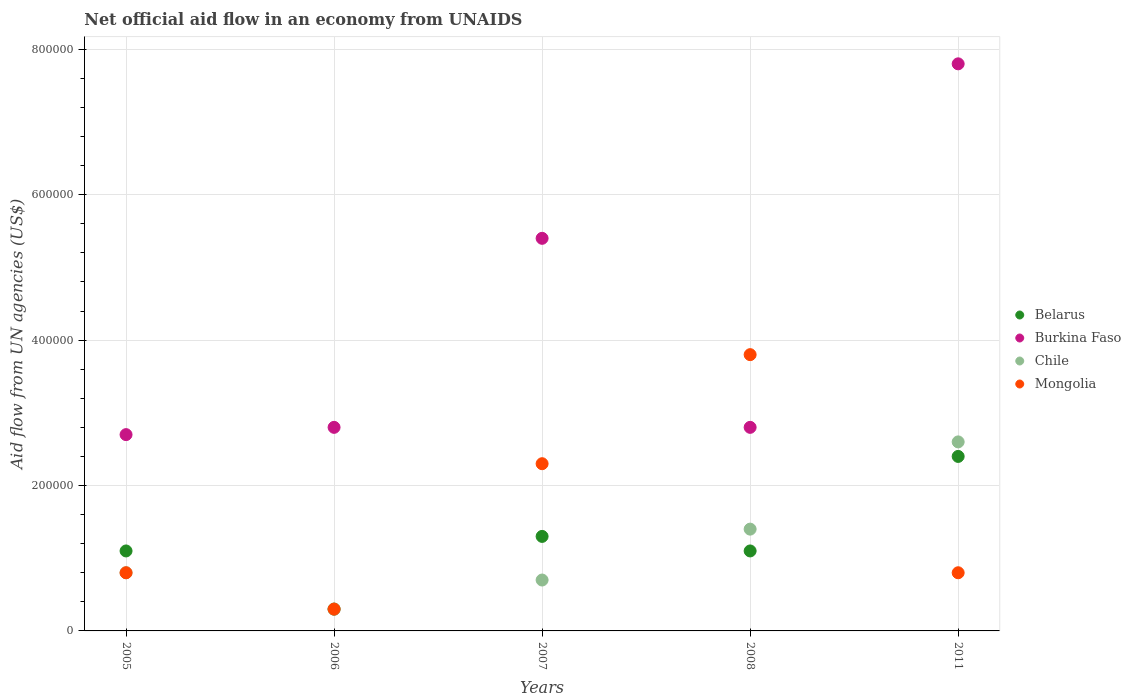Is the number of dotlines equal to the number of legend labels?
Offer a terse response. Yes. What is the net official aid flow in Burkina Faso in 2005?
Your answer should be very brief. 2.70e+05. Across all years, what is the minimum net official aid flow in Belarus?
Ensure brevity in your answer.  3.00e+04. In which year was the net official aid flow in Chile minimum?
Provide a succinct answer. 2006. What is the total net official aid flow in Belarus in the graph?
Keep it short and to the point. 6.20e+05. What is the difference between the net official aid flow in Mongolia in 2005 and the net official aid flow in Belarus in 2007?
Keep it short and to the point. -5.00e+04. What is the average net official aid flow in Belarus per year?
Provide a short and direct response. 1.24e+05. In the year 2008, what is the difference between the net official aid flow in Mongolia and net official aid flow in Chile?
Ensure brevity in your answer.  2.40e+05. What is the ratio of the net official aid flow in Belarus in 2006 to that in 2011?
Ensure brevity in your answer.  0.12. What is the difference between the highest and the second highest net official aid flow in Belarus?
Provide a succinct answer. 1.10e+05. Is it the case that in every year, the sum of the net official aid flow in Belarus and net official aid flow in Mongolia  is greater than the net official aid flow in Chile?
Your response must be concise. Yes. Is the net official aid flow in Mongolia strictly less than the net official aid flow in Chile over the years?
Give a very brief answer. No. How many dotlines are there?
Give a very brief answer. 4. How many years are there in the graph?
Give a very brief answer. 5. What is the difference between two consecutive major ticks on the Y-axis?
Provide a short and direct response. 2.00e+05. How are the legend labels stacked?
Offer a terse response. Vertical. What is the title of the graph?
Your answer should be compact. Net official aid flow in an economy from UNAIDS. What is the label or title of the Y-axis?
Make the answer very short. Aid flow from UN agencies (US$). What is the Aid flow from UN agencies (US$) of Belarus in 2005?
Offer a terse response. 1.10e+05. What is the Aid flow from UN agencies (US$) in Mongolia in 2005?
Offer a very short reply. 8.00e+04. What is the Aid flow from UN agencies (US$) of Chile in 2006?
Ensure brevity in your answer.  3.00e+04. What is the Aid flow from UN agencies (US$) in Belarus in 2007?
Make the answer very short. 1.30e+05. What is the Aid flow from UN agencies (US$) of Burkina Faso in 2007?
Offer a terse response. 5.40e+05. What is the Aid flow from UN agencies (US$) of Mongolia in 2007?
Give a very brief answer. 2.30e+05. What is the Aid flow from UN agencies (US$) in Mongolia in 2008?
Ensure brevity in your answer.  3.80e+05. What is the Aid flow from UN agencies (US$) of Belarus in 2011?
Offer a terse response. 2.40e+05. What is the Aid flow from UN agencies (US$) in Burkina Faso in 2011?
Make the answer very short. 7.80e+05. What is the Aid flow from UN agencies (US$) of Chile in 2011?
Provide a short and direct response. 2.60e+05. Across all years, what is the maximum Aid flow from UN agencies (US$) in Burkina Faso?
Your answer should be very brief. 7.80e+05. Across all years, what is the maximum Aid flow from UN agencies (US$) of Chile?
Ensure brevity in your answer.  2.60e+05. Across all years, what is the maximum Aid flow from UN agencies (US$) of Mongolia?
Your answer should be very brief. 3.80e+05. Across all years, what is the minimum Aid flow from UN agencies (US$) in Belarus?
Provide a succinct answer. 3.00e+04. What is the total Aid flow from UN agencies (US$) of Belarus in the graph?
Your response must be concise. 6.20e+05. What is the total Aid flow from UN agencies (US$) of Burkina Faso in the graph?
Provide a short and direct response. 2.15e+06. What is the total Aid flow from UN agencies (US$) in Chile in the graph?
Offer a very short reply. 5.80e+05. What is the difference between the Aid flow from UN agencies (US$) in Burkina Faso in 2005 and that in 2006?
Ensure brevity in your answer.  -10000. What is the difference between the Aid flow from UN agencies (US$) in Chile in 2005 and that in 2007?
Your answer should be compact. 10000. What is the difference between the Aid flow from UN agencies (US$) in Mongolia in 2005 and that in 2007?
Offer a terse response. -1.50e+05. What is the difference between the Aid flow from UN agencies (US$) in Chile in 2005 and that in 2008?
Your answer should be compact. -6.00e+04. What is the difference between the Aid flow from UN agencies (US$) of Burkina Faso in 2005 and that in 2011?
Keep it short and to the point. -5.10e+05. What is the difference between the Aid flow from UN agencies (US$) in Mongolia in 2005 and that in 2011?
Ensure brevity in your answer.  0. What is the difference between the Aid flow from UN agencies (US$) in Belarus in 2006 and that in 2007?
Offer a very short reply. -1.00e+05. What is the difference between the Aid flow from UN agencies (US$) of Chile in 2006 and that in 2007?
Provide a short and direct response. -4.00e+04. What is the difference between the Aid flow from UN agencies (US$) in Burkina Faso in 2006 and that in 2008?
Your response must be concise. 0. What is the difference between the Aid flow from UN agencies (US$) in Mongolia in 2006 and that in 2008?
Ensure brevity in your answer.  -3.50e+05. What is the difference between the Aid flow from UN agencies (US$) of Belarus in 2006 and that in 2011?
Offer a very short reply. -2.10e+05. What is the difference between the Aid flow from UN agencies (US$) of Burkina Faso in 2006 and that in 2011?
Provide a succinct answer. -5.00e+05. What is the difference between the Aid flow from UN agencies (US$) in Mongolia in 2007 and that in 2011?
Provide a succinct answer. 1.50e+05. What is the difference between the Aid flow from UN agencies (US$) of Burkina Faso in 2008 and that in 2011?
Make the answer very short. -5.00e+05. What is the difference between the Aid flow from UN agencies (US$) in Chile in 2008 and that in 2011?
Give a very brief answer. -1.20e+05. What is the difference between the Aid flow from UN agencies (US$) of Belarus in 2005 and the Aid flow from UN agencies (US$) of Burkina Faso in 2006?
Offer a terse response. -1.70e+05. What is the difference between the Aid flow from UN agencies (US$) of Belarus in 2005 and the Aid flow from UN agencies (US$) of Chile in 2006?
Make the answer very short. 8.00e+04. What is the difference between the Aid flow from UN agencies (US$) in Burkina Faso in 2005 and the Aid flow from UN agencies (US$) in Chile in 2006?
Your response must be concise. 2.40e+05. What is the difference between the Aid flow from UN agencies (US$) of Burkina Faso in 2005 and the Aid flow from UN agencies (US$) of Mongolia in 2006?
Make the answer very short. 2.40e+05. What is the difference between the Aid flow from UN agencies (US$) of Chile in 2005 and the Aid flow from UN agencies (US$) of Mongolia in 2006?
Give a very brief answer. 5.00e+04. What is the difference between the Aid flow from UN agencies (US$) of Belarus in 2005 and the Aid flow from UN agencies (US$) of Burkina Faso in 2007?
Give a very brief answer. -4.30e+05. What is the difference between the Aid flow from UN agencies (US$) of Belarus in 2005 and the Aid flow from UN agencies (US$) of Mongolia in 2007?
Provide a succinct answer. -1.20e+05. What is the difference between the Aid flow from UN agencies (US$) in Burkina Faso in 2005 and the Aid flow from UN agencies (US$) in Chile in 2007?
Keep it short and to the point. 2.00e+05. What is the difference between the Aid flow from UN agencies (US$) in Burkina Faso in 2005 and the Aid flow from UN agencies (US$) in Mongolia in 2007?
Ensure brevity in your answer.  4.00e+04. What is the difference between the Aid flow from UN agencies (US$) of Chile in 2005 and the Aid flow from UN agencies (US$) of Mongolia in 2007?
Your answer should be compact. -1.50e+05. What is the difference between the Aid flow from UN agencies (US$) in Belarus in 2005 and the Aid flow from UN agencies (US$) in Burkina Faso in 2008?
Your answer should be very brief. -1.70e+05. What is the difference between the Aid flow from UN agencies (US$) in Belarus in 2005 and the Aid flow from UN agencies (US$) in Mongolia in 2008?
Your answer should be very brief. -2.70e+05. What is the difference between the Aid flow from UN agencies (US$) of Burkina Faso in 2005 and the Aid flow from UN agencies (US$) of Chile in 2008?
Offer a very short reply. 1.30e+05. What is the difference between the Aid flow from UN agencies (US$) in Burkina Faso in 2005 and the Aid flow from UN agencies (US$) in Mongolia in 2008?
Ensure brevity in your answer.  -1.10e+05. What is the difference between the Aid flow from UN agencies (US$) in Belarus in 2005 and the Aid flow from UN agencies (US$) in Burkina Faso in 2011?
Give a very brief answer. -6.70e+05. What is the difference between the Aid flow from UN agencies (US$) of Burkina Faso in 2005 and the Aid flow from UN agencies (US$) of Chile in 2011?
Keep it short and to the point. 10000. What is the difference between the Aid flow from UN agencies (US$) in Burkina Faso in 2005 and the Aid flow from UN agencies (US$) in Mongolia in 2011?
Offer a terse response. 1.90e+05. What is the difference between the Aid flow from UN agencies (US$) in Chile in 2005 and the Aid flow from UN agencies (US$) in Mongolia in 2011?
Your answer should be compact. 0. What is the difference between the Aid flow from UN agencies (US$) in Belarus in 2006 and the Aid flow from UN agencies (US$) in Burkina Faso in 2007?
Make the answer very short. -5.10e+05. What is the difference between the Aid flow from UN agencies (US$) in Belarus in 2006 and the Aid flow from UN agencies (US$) in Chile in 2007?
Offer a terse response. -4.00e+04. What is the difference between the Aid flow from UN agencies (US$) of Belarus in 2006 and the Aid flow from UN agencies (US$) of Mongolia in 2007?
Provide a succinct answer. -2.00e+05. What is the difference between the Aid flow from UN agencies (US$) of Chile in 2006 and the Aid flow from UN agencies (US$) of Mongolia in 2007?
Keep it short and to the point. -2.00e+05. What is the difference between the Aid flow from UN agencies (US$) of Belarus in 2006 and the Aid flow from UN agencies (US$) of Mongolia in 2008?
Your answer should be very brief. -3.50e+05. What is the difference between the Aid flow from UN agencies (US$) in Burkina Faso in 2006 and the Aid flow from UN agencies (US$) in Mongolia in 2008?
Your answer should be very brief. -1.00e+05. What is the difference between the Aid flow from UN agencies (US$) of Chile in 2006 and the Aid flow from UN agencies (US$) of Mongolia in 2008?
Your response must be concise. -3.50e+05. What is the difference between the Aid flow from UN agencies (US$) in Belarus in 2006 and the Aid flow from UN agencies (US$) in Burkina Faso in 2011?
Ensure brevity in your answer.  -7.50e+05. What is the difference between the Aid flow from UN agencies (US$) of Chile in 2006 and the Aid flow from UN agencies (US$) of Mongolia in 2011?
Provide a succinct answer. -5.00e+04. What is the difference between the Aid flow from UN agencies (US$) of Belarus in 2007 and the Aid flow from UN agencies (US$) of Chile in 2008?
Your answer should be compact. -10000. What is the difference between the Aid flow from UN agencies (US$) of Burkina Faso in 2007 and the Aid flow from UN agencies (US$) of Chile in 2008?
Ensure brevity in your answer.  4.00e+05. What is the difference between the Aid flow from UN agencies (US$) of Chile in 2007 and the Aid flow from UN agencies (US$) of Mongolia in 2008?
Ensure brevity in your answer.  -3.10e+05. What is the difference between the Aid flow from UN agencies (US$) of Belarus in 2007 and the Aid flow from UN agencies (US$) of Burkina Faso in 2011?
Provide a succinct answer. -6.50e+05. What is the difference between the Aid flow from UN agencies (US$) of Belarus in 2007 and the Aid flow from UN agencies (US$) of Chile in 2011?
Provide a short and direct response. -1.30e+05. What is the difference between the Aid flow from UN agencies (US$) in Belarus in 2007 and the Aid flow from UN agencies (US$) in Mongolia in 2011?
Your answer should be very brief. 5.00e+04. What is the difference between the Aid flow from UN agencies (US$) in Belarus in 2008 and the Aid flow from UN agencies (US$) in Burkina Faso in 2011?
Your answer should be very brief. -6.70e+05. What is the difference between the Aid flow from UN agencies (US$) of Burkina Faso in 2008 and the Aid flow from UN agencies (US$) of Mongolia in 2011?
Ensure brevity in your answer.  2.00e+05. What is the average Aid flow from UN agencies (US$) of Belarus per year?
Provide a succinct answer. 1.24e+05. What is the average Aid flow from UN agencies (US$) of Chile per year?
Your answer should be compact. 1.16e+05. In the year 2005, what is the difference between the Aid flow from UN agencies (US$) in Belarus and Aid flow from UN agencies (US$) in Burkina Faso?
Your answer should be very brief. -1.60e+05. In the year 2005, what is the difference between the Aid flow from UN agencies (US$) in Belarus and Aid flow from UN agencies (US$) in Mongolia?
Keep it short and to the point. 3.00e+04. In the year 2005, what is the difference between the Aid flow from UN agencies (US$) in Burkina Faso and Aid flow from UN agencies (US$) in Mongolia?
Offer a terse response. 1.90e+05. In the year 2005, what is the difference between the Aid flow from UN agencies (US$) in Chile and Aid flow from UN agencies (US$) in Mongolia?
Provide a short and direct response. 0. In the year 2006, what is the difference between the Aid flow from UN agencies (US$) of Belarus and Aid flow from UN agencies (US$) of Chile?
Your answer should be very brief. 0. In the year 2006, what is the difference between the Aid flow from UN agencies (US$) in Burkina Faso and Aid flow from UN agencies (US$) in Chile?
Offer a very short reply. 2.50e+05. In the year 2006, what is the difference between the Aid flow from UN agencies (US$) of Chile and Aid flow from UN agencies (US$) of Mongolia?
Your answer should be compact. 0. In the year 2007, what is the difference between the Aid flow from UN agencies (US$) of Belarus and Aid flow from UN agencies (US$) of Burkina Faso?
Provide a succinct answer. -4.10e+05. In the year 2007, what is the difference between the Aid flow from UN agencies (US$) in Belarus and Aid flow from UN agencies (US$) in Chile?
Offer a terse response. 6.00e+04. In the year 2007, what is the difference between the Aid flow from UN agencies (US$) in Belarus and Aid flow from UN agencies (US$) in Mongolia?
Keep it short and to the point. -1.00e+05. In the year 2007, what is the difference between the Aid flow from UN agencies (US$) in Burkina Faso and Aid flow from UN agencies (US$) in Mongolia?
Give a very brief answer. 3.10e+05. In the year 2008, what is the difference between the Aid flow from UN agencies (US$) in Belarus and Aid flow from UN agencies (US$) in Mongolia?
Give a very brief answer. -2.70e+05. In the year 2008, what is the difference between the Aid flow from UN agencies (US$) of Burkina Faso and Aid flow from UN agencies (US$) of Chile?
Offer a terse response. 1.40e+05. In the year 2008, what is the difference between the Aid flow from UN agencies (US$) of Burkina Faso and Aid flow from UN agencies (US$) of Mongolia?
Make the answer very short. -1.00e+05. In the year 2008, what is the difference between the Aid flow from UN agencies (US$) of Chile and Aid flow from UN agencies (US$) of Mongolia?
Your answer should be compact. -2.40e+05. In the year 2011, what is the difference between the Aid flow from UN agencies (US$) in Belarus and Aid flow from UN agencies (US$) in Burkina Faso?
Offer a terse response. -5.40e+05. In the year 2011, what is the difference between the Aid flow from UN agencies (US$) of Belarus and Aid flow from UN agencies (US$) of Chile?
Provide a succinct answer. -2.00e+04. In the year 2011, what is the difference between the Aid flow from UN agencies (US$) of Burkina Faso and Aid flow from UN agencies (US$) of Chile?
Your response must be concise. 5.20e+05. In the year 2011, what is the difference between the Aid flow from UN agencies (US$) of Burkina Faso and Aid flow from UN agencies (US$) of Mongolia?
Make the answer very short. 7.00e+05. What is the ratio of the Aid flow from UN agencies (US$) of Belarus in 2005 to that in 2006?
Offer a very short reply. 3.67. What is the ratio of the Aid flow from UN agencies (US$) of Chile in 2005 to that in 2006?
Make the answer very short. 2.67. What is the ratio of the Aid flow from UN agencies (US$) of Mongolia in 2005 to that in 2006?
Offer a terse response. 2.67. What is the ratio of the Aid flow from UN agencies (US$) in Belarus in 2005 to that in 2007?
Keep it short and to the point. 0.85. What is the ratio of the Aid flow from UN agencies (US$) of Burkina Faso in 2005 to that in 2007?
Give a very brief answer. 0.5. What is the ratio of the Aid flow from UN agencies (US$) in Chile in 2005 to that in 2007?
Your answer should be compact. 1.14. What is the ratio of the Aid flow from UN agencies (US$) in Mongolia in 2005 to that in 2007?
Give a very brief answer. 0.35. What is the ratio of the Aid flow from UN agencies (US$) of Belarus in 2005 to that in 2008?
Give a very brief answer. 1. What is the ratio of the Aid flow from UN agencies (US$) of Chile in 2005 to that in 2008?
Your answer should be very brief. 0.57. What is the ratio of the Aid flow from UN agencies (US$) of Mongolia in 2005 to that in 2008?
Offer a terse response. 0.21. What is the ratio of the Aid flow from UN agencies (US$) of Belarus in 2005 to that in 2011?
Give a very brief answer. 0.46. What is the ratio of the Aid flow from UN agencies (US$) in Burkina Faso in 2005 to that in 2011?
Your answer should be very brief. 0.35. What is the ratio of the Aid flow from UN agencies (US$) in Chile in 2005 to that in 2011?
Ensure brevity in your answer.  0.31. What is the ratio of the Aid flow from UN agencies (US$) of Belarus in 2006 to that in 2007?
Provide a short and direct response. 0.23. What is the ratio of the Aid flow from UN agencies (US$) of Burkina Faso in 2006 to that in 2007?
Your answer should be very brief. 0.52. What is the ratio of the Aid flow from UN agencies (US$) of Chile in 2006 to that in 2007?
Keep it short and to the point. 0.43. What is the ratio of the Aid flow from UN agencies (US$) in Mongolia in 2006 to that in 2007?
Your answer should be compact. 0.13. What is the ratio of the Aid flow from UN agencies (US$) in Belarus in 2006 to that in 2008?
Your response must be concise. 0.27. What is the ratio of the Aid flow from UN agencies (US$) of Burkina Faso in 2006 to that in 2008?
Give a very brief answer. 1. What is the ratio of the Aid flow from UN agencies (US$) in Chile in 2006 to that in 2008?
Make the answer very short. 0.21. What is the ratio of the Aid flow from UN agencies (US$) of Mongolia in 2006 to that in 2008?
Provide a succinct answer. 0.08. What is the ratio of the Aid flow from UN agencies (US$) of Burkina Faso in 2006 to that in 2011?
Keep it short and to the point. 0.36. What is the ratio of the Aid flow from UN agencies (US$) of Chile in 2006 to that in 2011?
Provide a succinct answer. 0.12. What is the ratio of the Aid flow from UN agencies (US$) of Mongolia in 2006 to that in 2011?
Make the answer very short. 0.38. What is the ratio of the Aid flow from UN agencies (US$) in Belarus in 2007 to that in 2008?
Give a very brief answer. 1.18. What is the ratio of the Aid flow from UN agencies (US$) of Burkina Faso in 2007 to that in 2008?
Keep it short and to the point. 1.93. What is the ratio of the Aid flow from UN agencies (US$) of Chile in 2007 to that in 2008?
Provide a succinct answer. 0.5. What is the ratio of the Aid flow from UN agencies (US$) in Mongolia in 2007 to that in 2008?
Provide a succinct answer. 0.61. What is the ratio of the Aid flow from UN agencies (US$) of Belarus in 2007 to that in 2011?
Offer a very short reply. 0.54. What is the ratio of the Aid flow from UN agencies (US$) of Burkina Faso in 2007 to that in 2011?
Your answer should be very brief. 0.69. What is the ratio of the Aid flow from UN agencies (US$) in Chile in 2007 to that in 2011?
Your response must be concise. 0.27. What is the ratio of the Aid flow from UN agencies (US$) in Mongolia in 2007 to that in 2011?
Give a very brief answer. 2.88. What is the ratio of the Aid flow from UN agencies (US$) of Belarus in 2008 to that in 2011?
Give a very brief answer. 0.46. What is the ratio of the Aid flow from UN agencies (US$) in Burkina Faso in 2008 to that in 2011?
Your answer should be compact. 0.36. What is the ratio of the Aid flow from UN agencies (US$) of Chile in 2008 to that in 2011?
Offer a very short reply. 0.54. What is the ratio of the Aid flow from UN agencies (US$) in Mongolia in 2008 to that in 2011?
Your response must be concise. 4.75. What is the difference between the highest and the second highest Aid flow from UN agencies (US$) of Belarus?
Your answer should be compact. 1.10e+05. What is the difference between the highest and the second highest Aid flow from UN agencies (US$) of Burkina Faso?
Ensure brevity in your answer.  2.40e+05. What is the difference between the highest and the lowest Aid flow from UN agencies (US$) of Belarus?
Provide a short and direct response. 2.10e+05. What is the difference between the highest and the lowest Aid flow from UN agencies (US$) in Burkina Faso?
Provide a short and direct response. 5.10e+05. What is the difference between the highest and the lowest Aid flow from UN agencies (US$) of Mongolia?
Make the answer very short. 3.50e+05. 